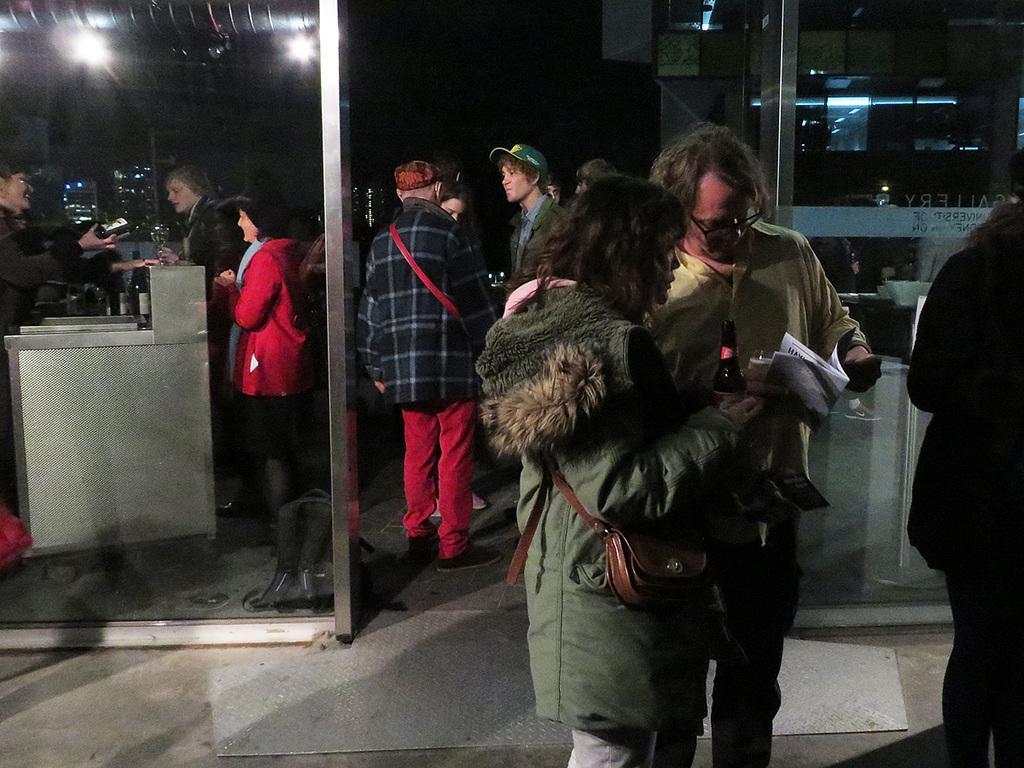Describe this image in one or two sentences. On the right side two people are wearing jackets, standing, holding a bottle and papers in the hands and looking at the paper. At the back of these people there are two glasses. Behind these few people are standing. On the left side there is a metal box. Few people are standing on the both sides of it. In the background, I can see some buildings in the dark. At the top there are few lights. 